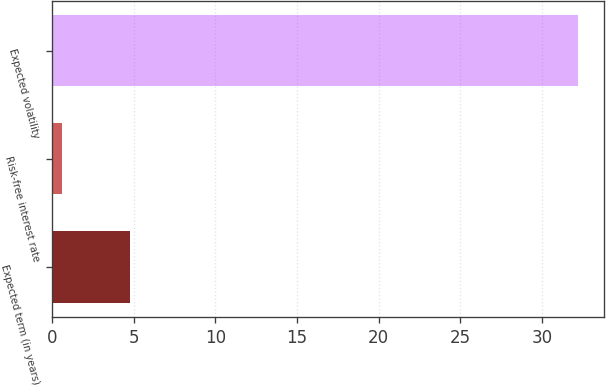<chart> <loc_0><loc_0><loc_500><loc_500><bar_chart><fcel>Expected term (in years)<fcel>Risk-free interest rate<fcel>Expected volatility<nl><fcel>4.76<fcel>0.6<fcel>32.2<nl></chart> 